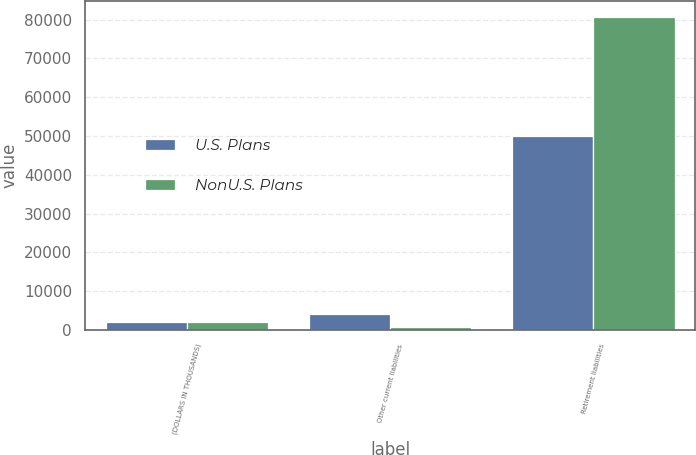Convert chart to OTSL. <chart><loc_0><loc_0><loc_500><loc_500><stacked_bar_chart><ecel><fcel>(DOLLARS IN THOUSANDS)<fcel>Other current liabilities<fcel>Retirement liabilities<nl><fcel>U.S. Plans<fcel>2017<fcel>4049<fcel>49981<nl><fcel>NonU.S. Plans<fcel>2017<fcel>652<fcel>80694<nl></chart> 